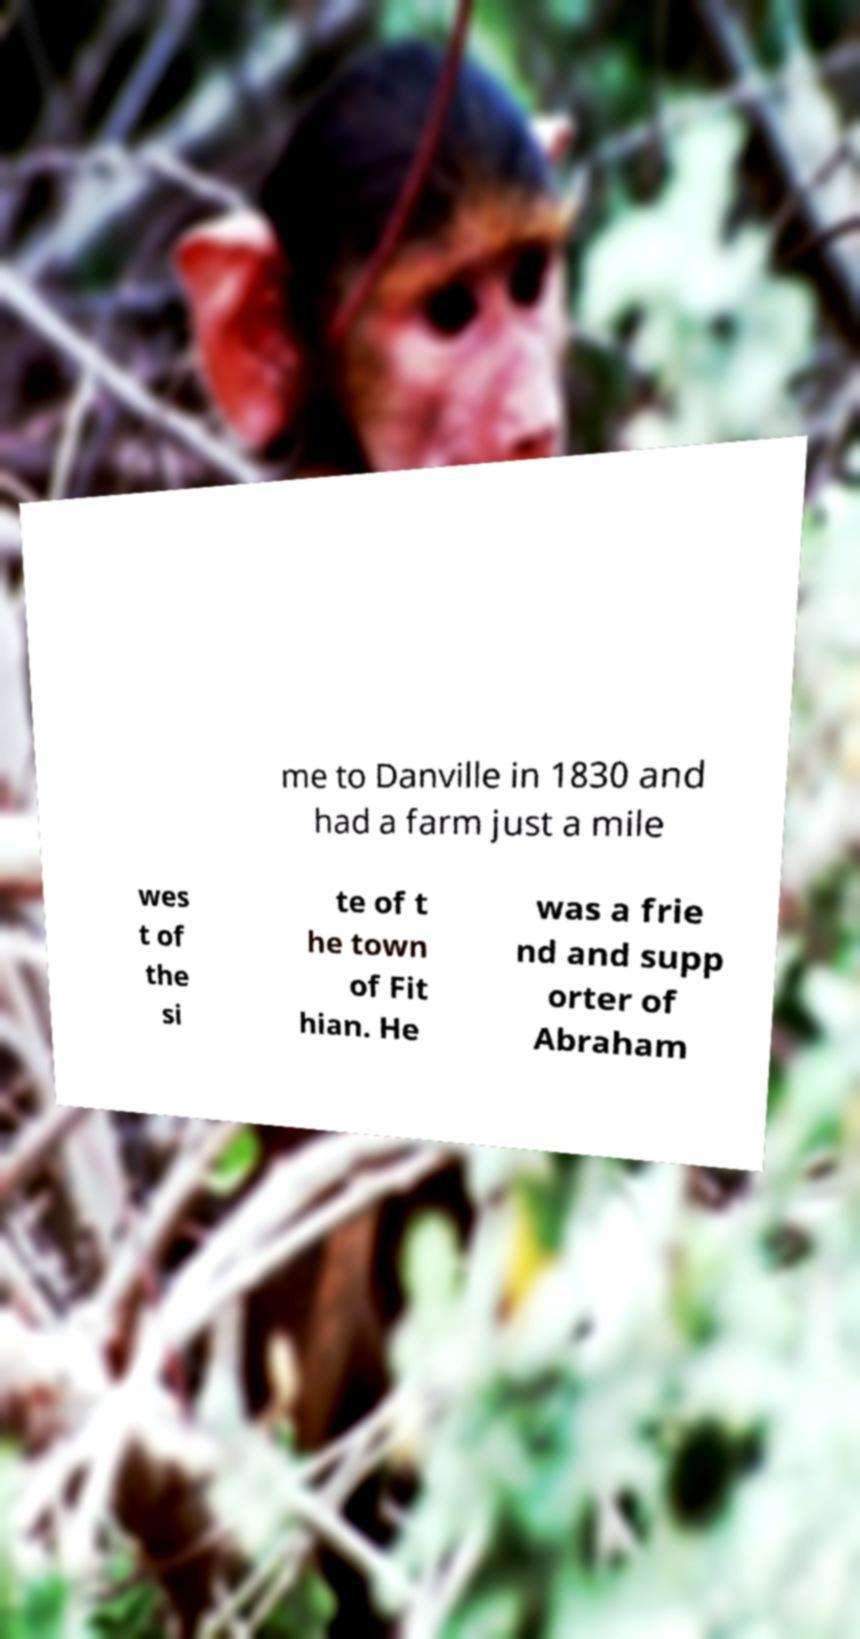I need the written content from this picture converted into text. Can you do that? me to Danville in 1830 and had a farm just a mile wes t of the si te of t he town of Fit hian. He was a frie nd and supp orter of Abraham 